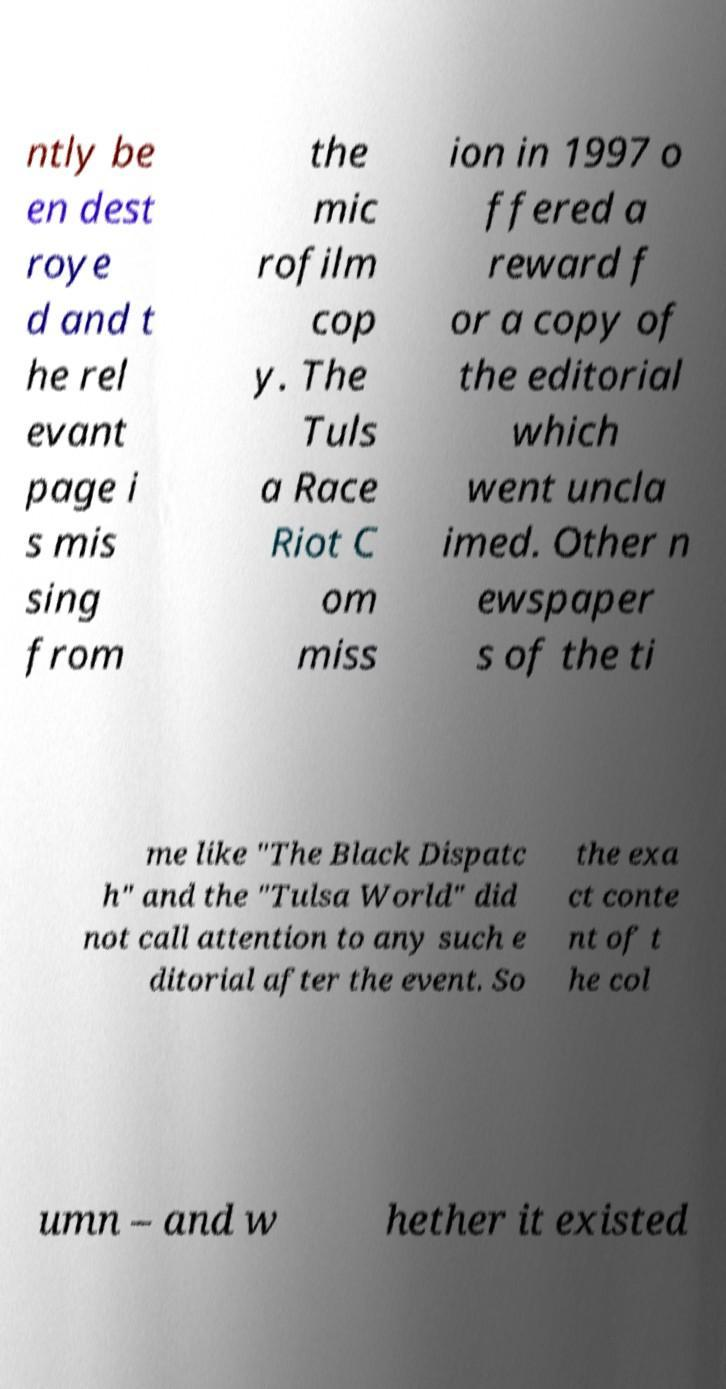Can you read and provide the text displayed in the image?This photo seems to have some interesting text. Can you extract and type it out for me? ntly be en dest roye d and t he rel evant page i s mis sing from the mic rofilm cop y. The Tuls a Race Riot C om miss ion in 1997 o ffered a reward f or a copy of the editorial which went uncla imed. Other n ewspaper s of the ti me like "The Black Dispatc h" and the "Tulsa World" did not call attention to any such e ditorial after the event. So the exa ct conte nt of t he col umn – and w hether it existed 